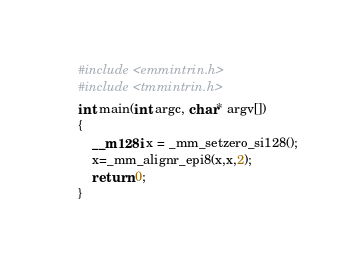Convert code to text. <code><loc_0><loc_0><loc_500><loc_500><_C++_>#include <emmintrin.h>
#include <tmmintrin.h>
int main(int argc, char* argv[])
{
    __m128i x = _mm_setzero_si128();
    x=_mm_alignr_epi8(x,x,2);
    return 0;
}
</code> 